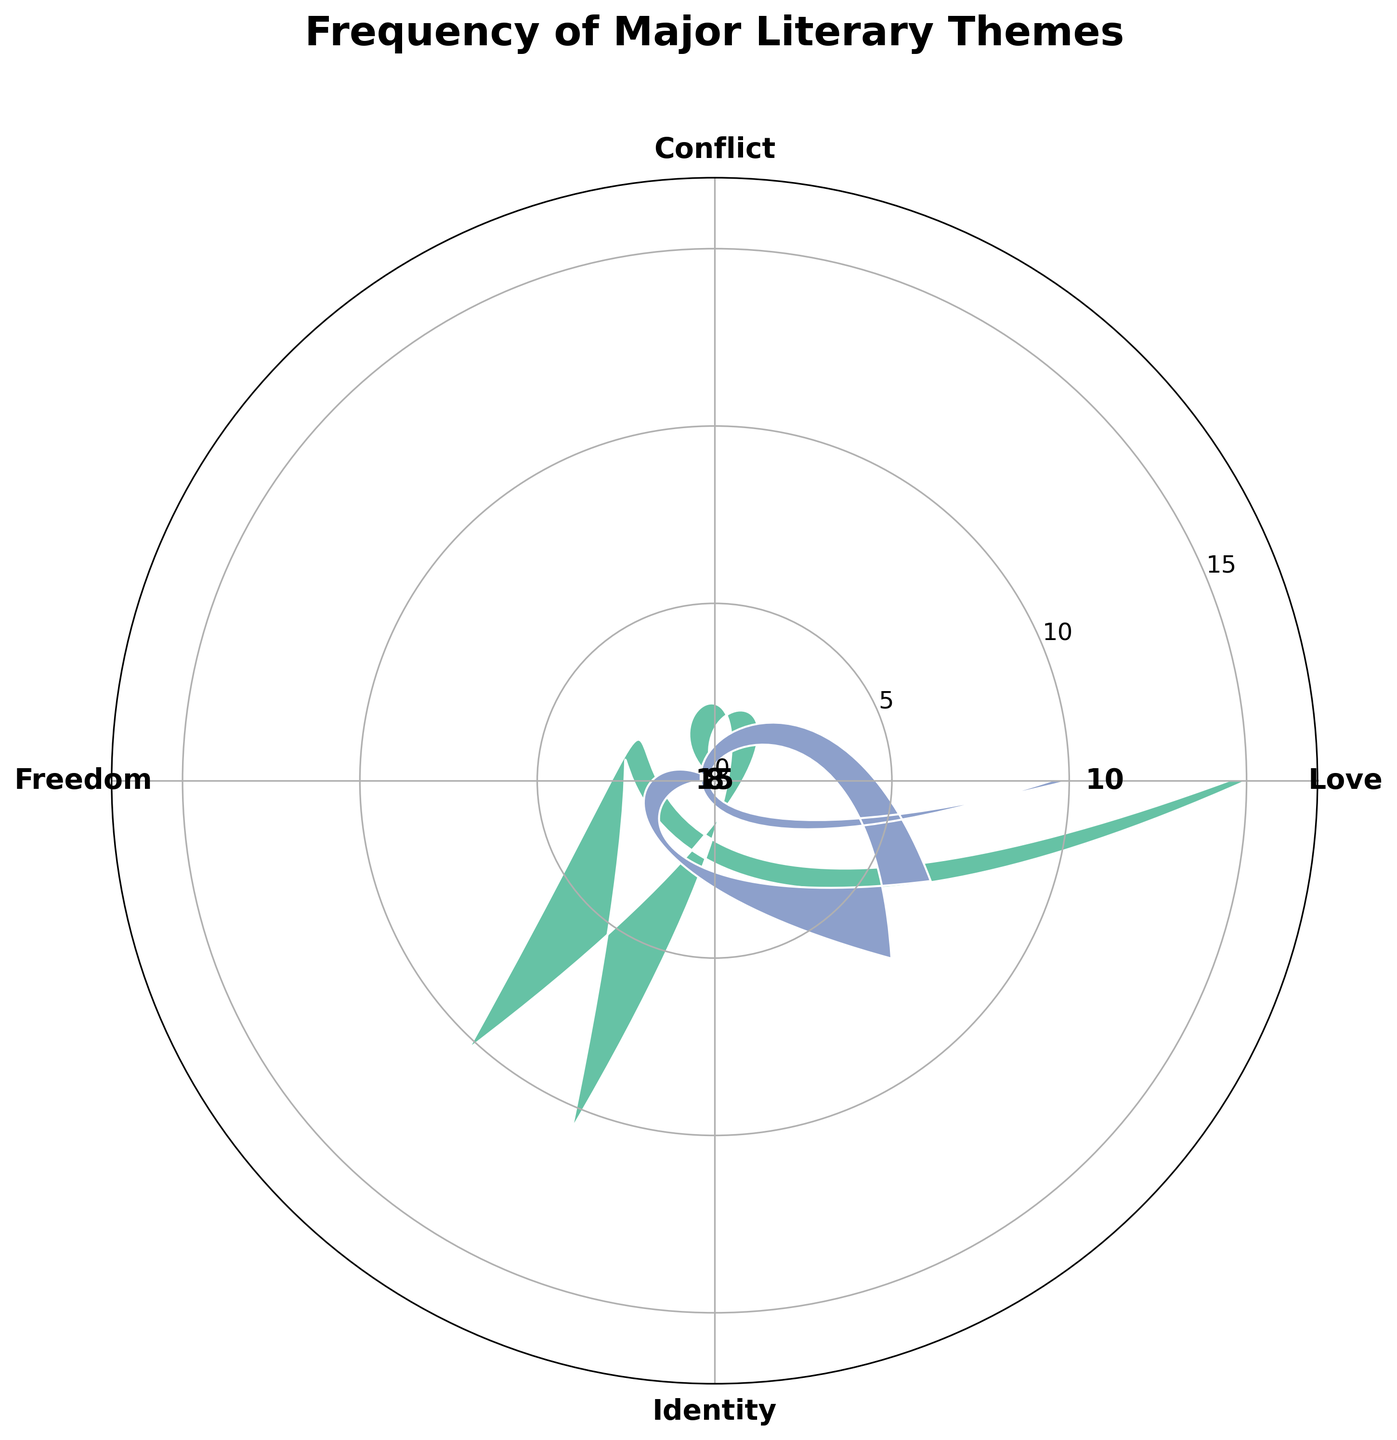What is the theme with the highest frequency? The theme with the highest frequency can be identified by comparing the lengths of the wedges. The largest wedge corresponds to the theme "Love" with a frequency of 15.
Answer: Love Which theme has the second highest frequency? By comparing the lengths of the wedges, we can see that the second largest wedge corresponds to the theme "Identity" with a frequency of 12.
Answer: Identity What are the two least frequent themes and their frequencies? By comparing the wedges, we observe that "Freedom" and "Conflict" have the smallest wedge lengths. "Freedom" has a frequency of 8 and "Conflict" has a frequency of 10.
Answer: Freedom (8), Conflict (10) What is the sum of the frequencies for the themes "Love" and "Conflict"? Add the frequencies of "Love" and "Conflict". "Love" has a frequency of 15 and "Conflict" has a frequency of 10, so the sum is 15 + 10.
Answer: 25 How many more times is the theme "Love" represented compared to "Freedom"? Subtract the frequency of "Freedom" from the frequency of "Love". "Love" has a frequency of 15 and "Freedom" has a frequency of 8, so the difference is 15 - 8.
Answer: 7 What percentage of the total frequency does the theme "Identity" represent? First, calculate the total frequency by summing all the frequencies (15 + 10 + 8 + 12 = 45). Then, divide the frequency of "Identity" (12) by the total frequency (45) and multiply by 100 to get the percentage. \( (12 / 45) \times 100 \approx 26.67\% \).
Answer: 26.67% What is the average frequency of all the themes? Sum all the frequencies (15 + 10 + 8 + 12 = 45) and divide by the number of themes (4). The average frequency is 45 / 4.
Answer: 11.25 Which theme has the smallest wedge and what is its frequency? The smallest wedge can be identified by the shortest wedge length, which corresponds to the theme "Freedom" with a frequency of 8.
Answer: Freedom (8) 